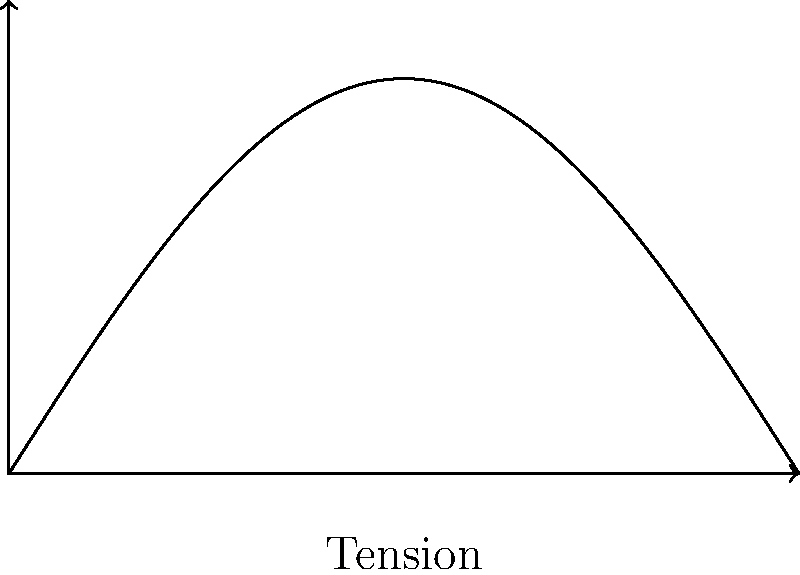As a rockstar who's played countless gigs at the Whisky A Go Go, you know the importance of a well-tuned guitar. Consider a guitar string under tension $T$, with a length $L$. The string's displacement $y$ as a function of position $x$ is given by $y(x) = A \sin(\frac{\pi x}{L})$, where $A$ is the amplitude. What is the maximum stress $\sigma_{max}$ in the string in terms of $T$, $A$, $L$, and the string's cross-sectional area $S$? Let's approach this step-by-step:

1) The stress in a string is related to the tension and the curvature of the string. The general formula for stress in a vibrating string is:

   $$\sigma = \frac{T}{S} \left(1 + \left(\frac{dy}{dx}\right)^2\right)^{1/2}$$

2) We need to find the maximum value of this expression. The maximum will occur where the slope $\frac{dy}{dx}$ is at its maximum.

3) To find $\frac{dy}{dx}$, we differentiate $y(x)$:

   $$\frac{dy}{dx} = A \cdot \frac{\pi}{L} \cos(\frac{\pi x}{L})$$

4) The maximum value of cosine is 1, so the maximum slope is:

   $$\left(\frac{dy}{dx}\right)_{max} = A \cdot \frac{\pi}{L}$$

5) Substituting this back into our stress equation:

   $$\sigma_{max} = \frac{T}{S} \left(1 + \left(A \cdot \frac{\pi}{L}\right)^2\right)^{1/2}$$

6) This can be simplified to:

   $$\sigma_{max} = \frac{T}{S} \sqrt{1 + \left(\frac{A\pi}{L}\right)^2}$$

This is our final expression for the maximum stress in the string.
Answer: $\frac{T}{S} \sqrt{1 + \left(\frac{A\pi}{L}\right)^2}$ 